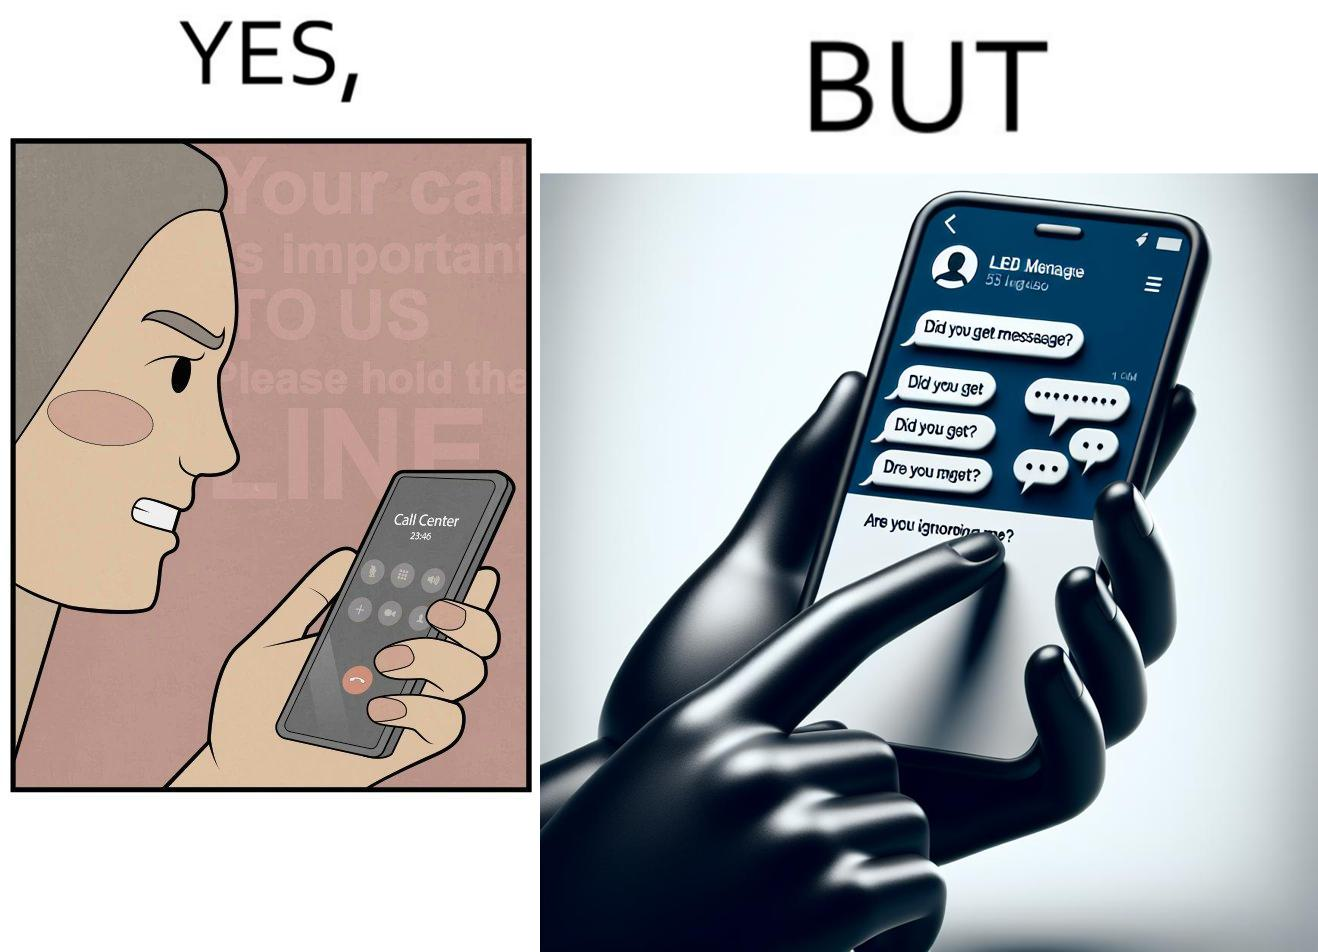Does this image contain satire or humor? Yes, this image is satirical. 